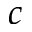<formula> <loc_0><loc_0><loc_500><loc_500>c</formula> 